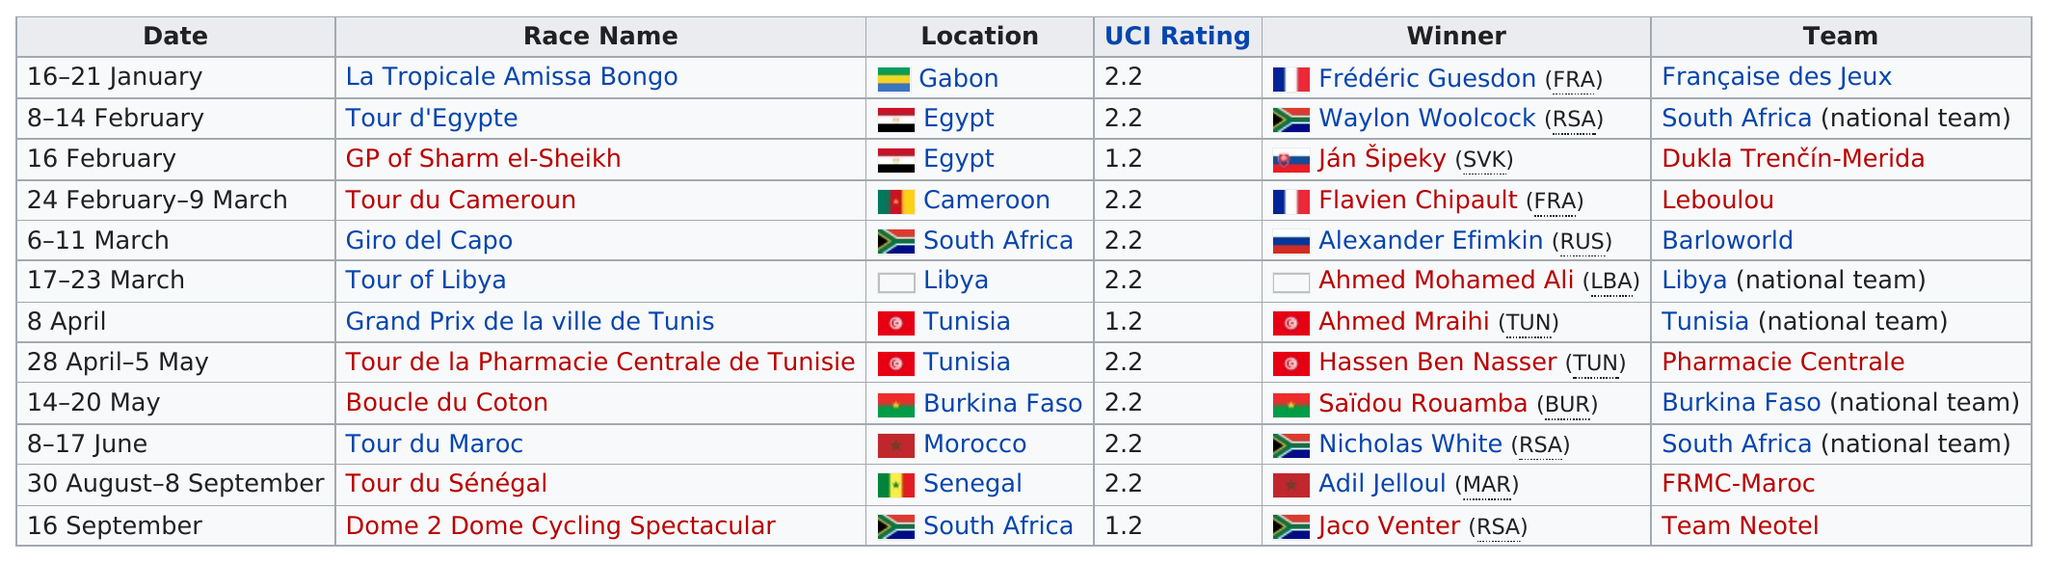Give some essential details in this illustration. The last race of the Tour had a UCI rating of 1.2. Frederic Guesdon (FRA) was the winner of the first race on the tour. What other location besides Egypt holds two races? Tunisia! The Tour du Cameroun was the only race held in Cameroon. Out of the three races, only one had a UCI rating of less than 2.0. 